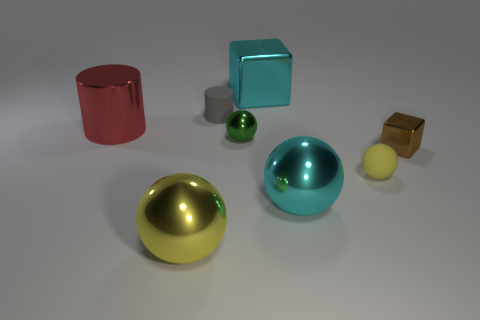What size is the yellow thing that is on the left side of the shiny thing behind the metallic cylinder?
Ensure brevity in your answer.  Large. What size is the shiny ball that is the same color as the big shiny cube?
Keep it short and to the point. Large. What number of other objects are there of the same size as the red cylinder?
Your answer should be compact. 3. What number of blue shiny cylinders are there?
Provide a succinct answer. 0. Is the matte sphere the same size as the cyan metallic block?
Offer a very short reply. No. How many other things are the same shape as the gray object?
Offer a very short reply. 1. What is the material of the big cyan object that is behind the large cyan thing in front of the matte cylinder?
Your answer should be very brief. Metal. Are there any green spheres right of the tiny rubber sphere?
Make the answer very short. No. Is the size of the cyan shiny ball the same as the metallic sphere that is behind the cyan ball?
Your response must be concise. No. What is the size of the other rubber object that is the same shape as the red thing?
Offer a terse response. Small. 